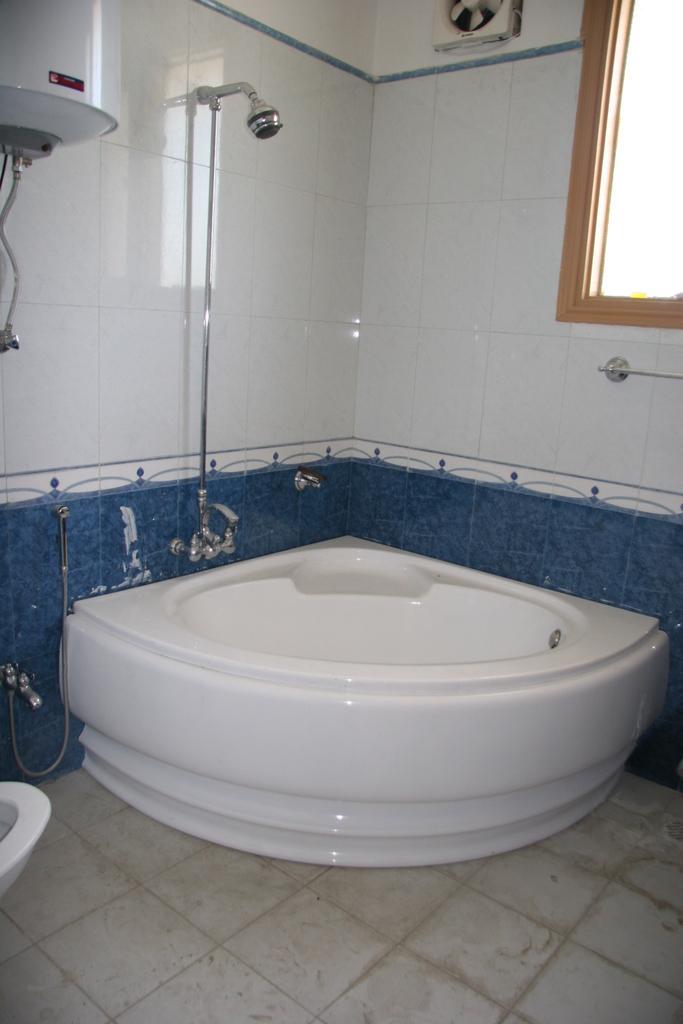Please provide a concise description of this image. This picture is clicked in the washroom. Here, we see bathtub. Behind that, we see a wall which is made up of white color tiles. On the right side, we see a window. On the left side, we see a shower and a geyser. In the left bottom, we see a toilet seat. 